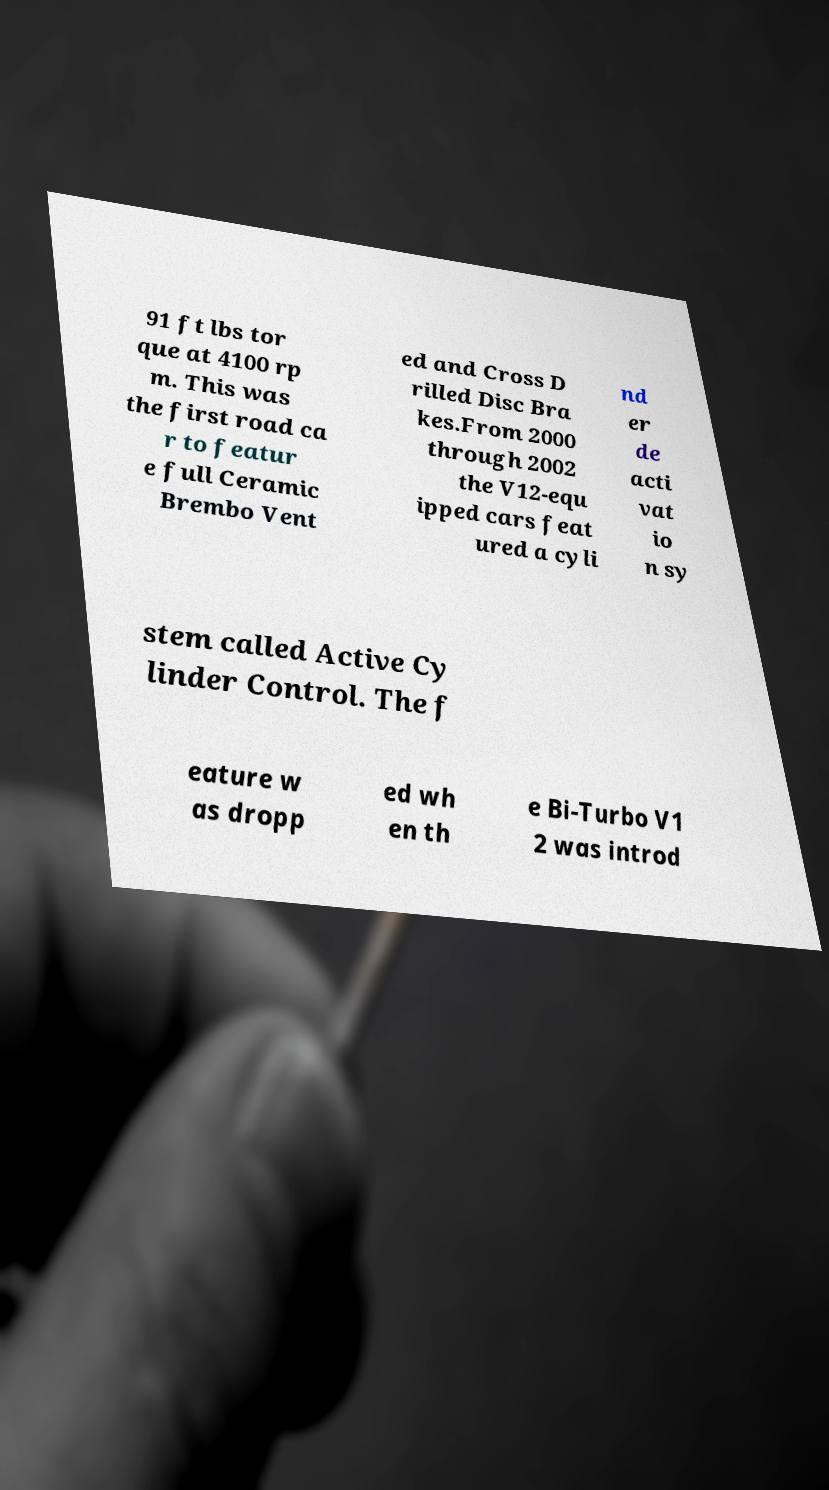Please read and relay the text visible in this image. What does it say? 91 ft lbs tor que at 4100 rp m. This was the first road ca r to featur e full Ceramic Brembo Vent ed and Cross D rilled Disc Bra kes.From 2000 through 2002 the V12-equ ipped cars feat ured a cyli nd er de acti vat io n sy stem called Active Cy linder Control. The f eature w as dropp ed wh en th e Bi-Turbo V1 2 was introd 